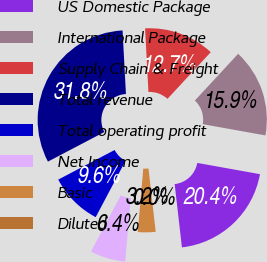<chart> <loc_0><loc_0><loc_500><loc_500><pie_chart><fcel>US Domestic Package<fcel>International Package<fcel>Supply Chain & Freight<fcel>Total revenue<fcel>Total operating profit<fcel>Net Income<fcel>Basic<fcel>Diluted<nl><fcel>20.36%<fcel>15.93%<fcel>12.74%<fcel>31.85%<fcel>9.56%<fcel>6.37%<fcel>3.19%<fcel>0.0%<nl></chart> 